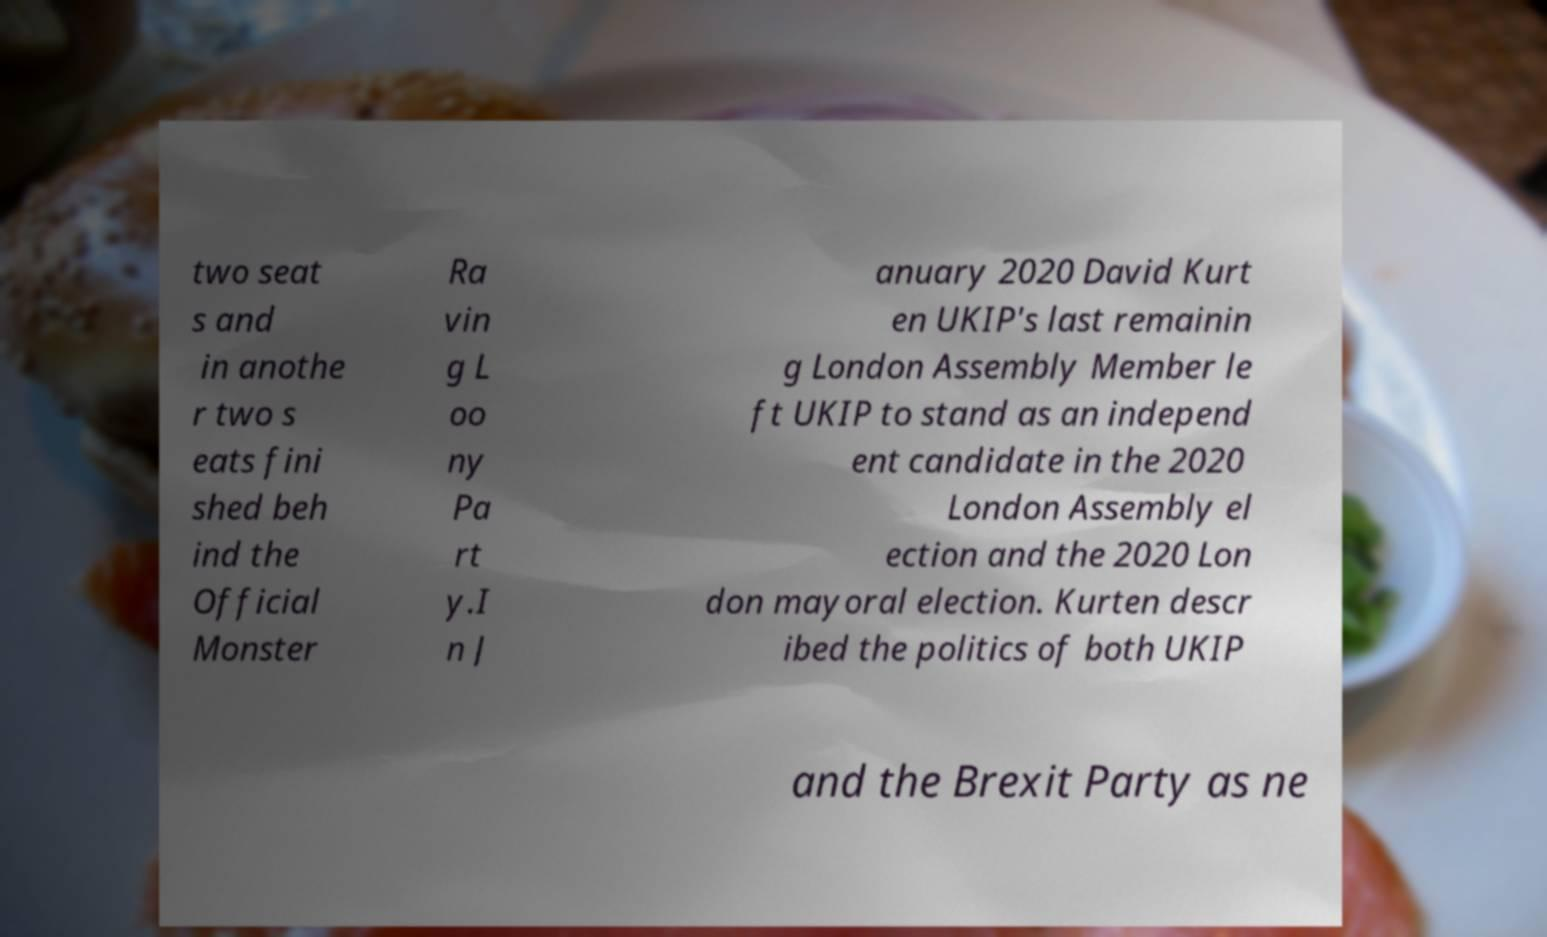Can you read and provide the text displayed in the image?This photo seems to have some interesting text. Can you extract and type it out for me? two seat s and in anothe r two s eats fini shed beh ind the Official Monster Ra vin g L oo ny Pa rt y.I n J anuary 2020 David Kurt en UKIP's last remainin g London Assembly Member le ft UKIP to stand as an independ ent candidate in the 2020 London Assembly el ection and the 2020 Lon don mayoral election. Kurten descr ibed the politics of both UKIP and the Brexit Party as ne 